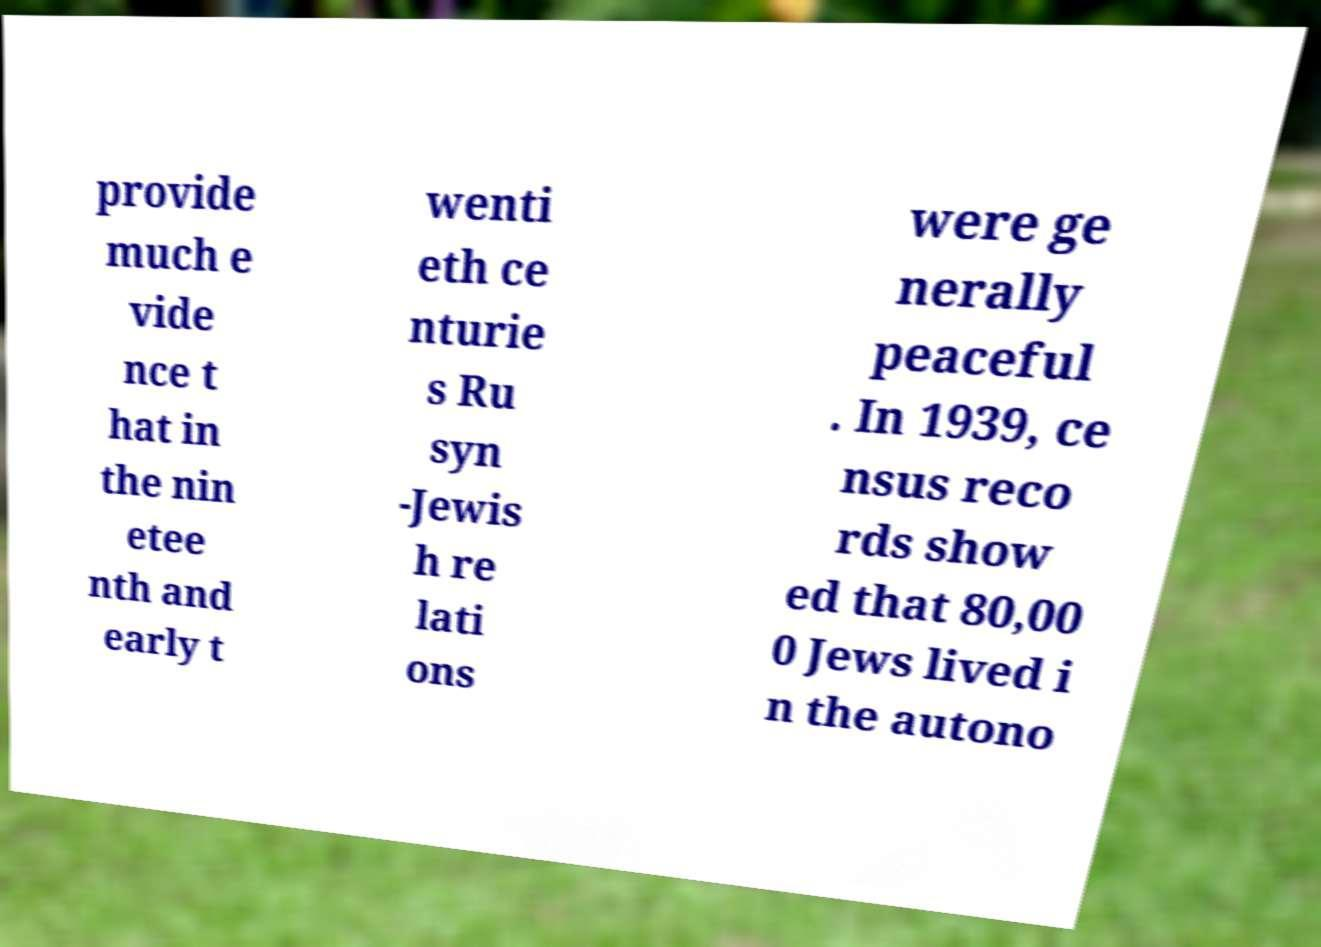Please read and relay the text visible in this image. What does it say? provide much e vide nce t hat in the nin etee nth and early t wenti eth ce nturie s Ru syn -Jewis h re lati ons were ge nerally peaceful . In 1939, ce nsus reco rds show ed that 80,00 0 Jews lived i n the autono 